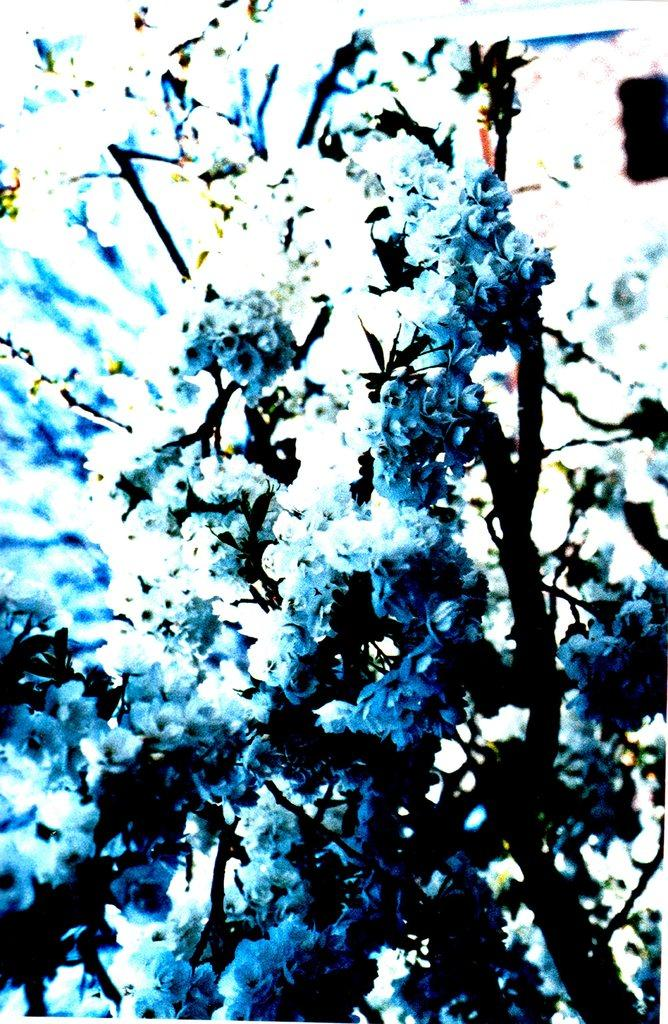What type of living organism can be seen in the image? There is a plant in the image. What type of yak can be seen grooming itself with a comb in the image? There is no yak or comb present in the image; it only features a plant. 